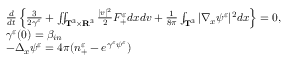<formula> <loc_0><loc_0><loc_500><loc_500>\begin{array} { r l } & { \frac { d } { d t } \left \{ \frac { 3 } { 2 \gamma ^ { \varepsilon } } + \iint _ { \mathbf T ^ { 3 } \times \mathbf R ^ { 3 } } \frac { | v | ^ { 2 } } { 2 } F _ { + } ^ { \varepsilon } d x d v + \frac { 1 } { 8 \pi } \int _ { \mathbf T ^ { 3 } } | \nabla _ { x } \psi ^ { \varepsilon } | ^ { 2 } d x \right \} = 0 , } \\ & { \gamma ^ { \varepsilon } ( 0 ) = \beta _ { i n } } \\ & { - \Delta _ { x } \psi ^ { \varepsilon } = 4 \pi ( n _ { + } ^ { \varepsilon } - e ^ { \gamma ^ { \varepsilon } \psi ^ { \varepsilon } } ) } \end{array}</formula> 